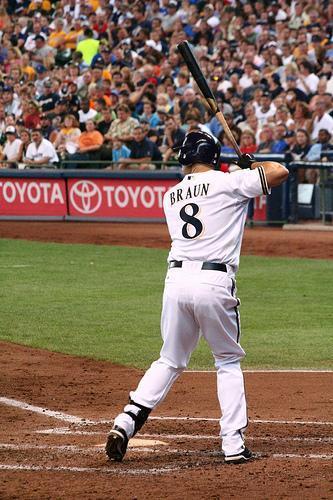How many baseball players are in this picture?
Give a very brief answer. 1. How many people are there?
Give a very brief answer. 2. 